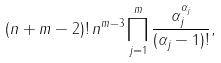Convert formula to latex. <formula><loc_0><loc_0><loc_500><loc_500>( n + m - 2 ) ! \, n ^ { m - 3 } \prod _ { j = 1 } ^ { m } \frac { \alpha _ { j } ^ { \alpha _ { j } } } { ( \alpha _ { j } - 1 ) ! } ,</formula> 